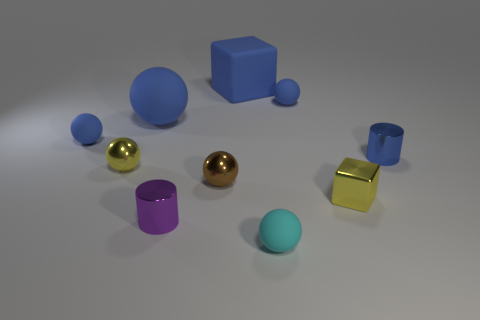How many blue balls must be subtracted to get 1 blue balls? 2 Subtract all small brown metallic spheres. How many spheres are left? 5 Subtract all blue cylinders. How many cylinders are left? 1 Subtract all cylinders. How many objects are left? 8 Subtract 1 cubes. How many cubes are left? 1 Subtract all purple cylinders. Subtract all gray blocks. How many cylinders are left? 1 Subtract all cyan spheres. How many blue blocks are left? 1 Subtract all small yellow metallic spheres. Subtract all tiny blue balls. How many objects are left? 7 Add 6 tiny cyan matte things. How many tiny cyan matte things are left? 7 Add 5 cyan cubes. How many cyan cubes exist? 5 